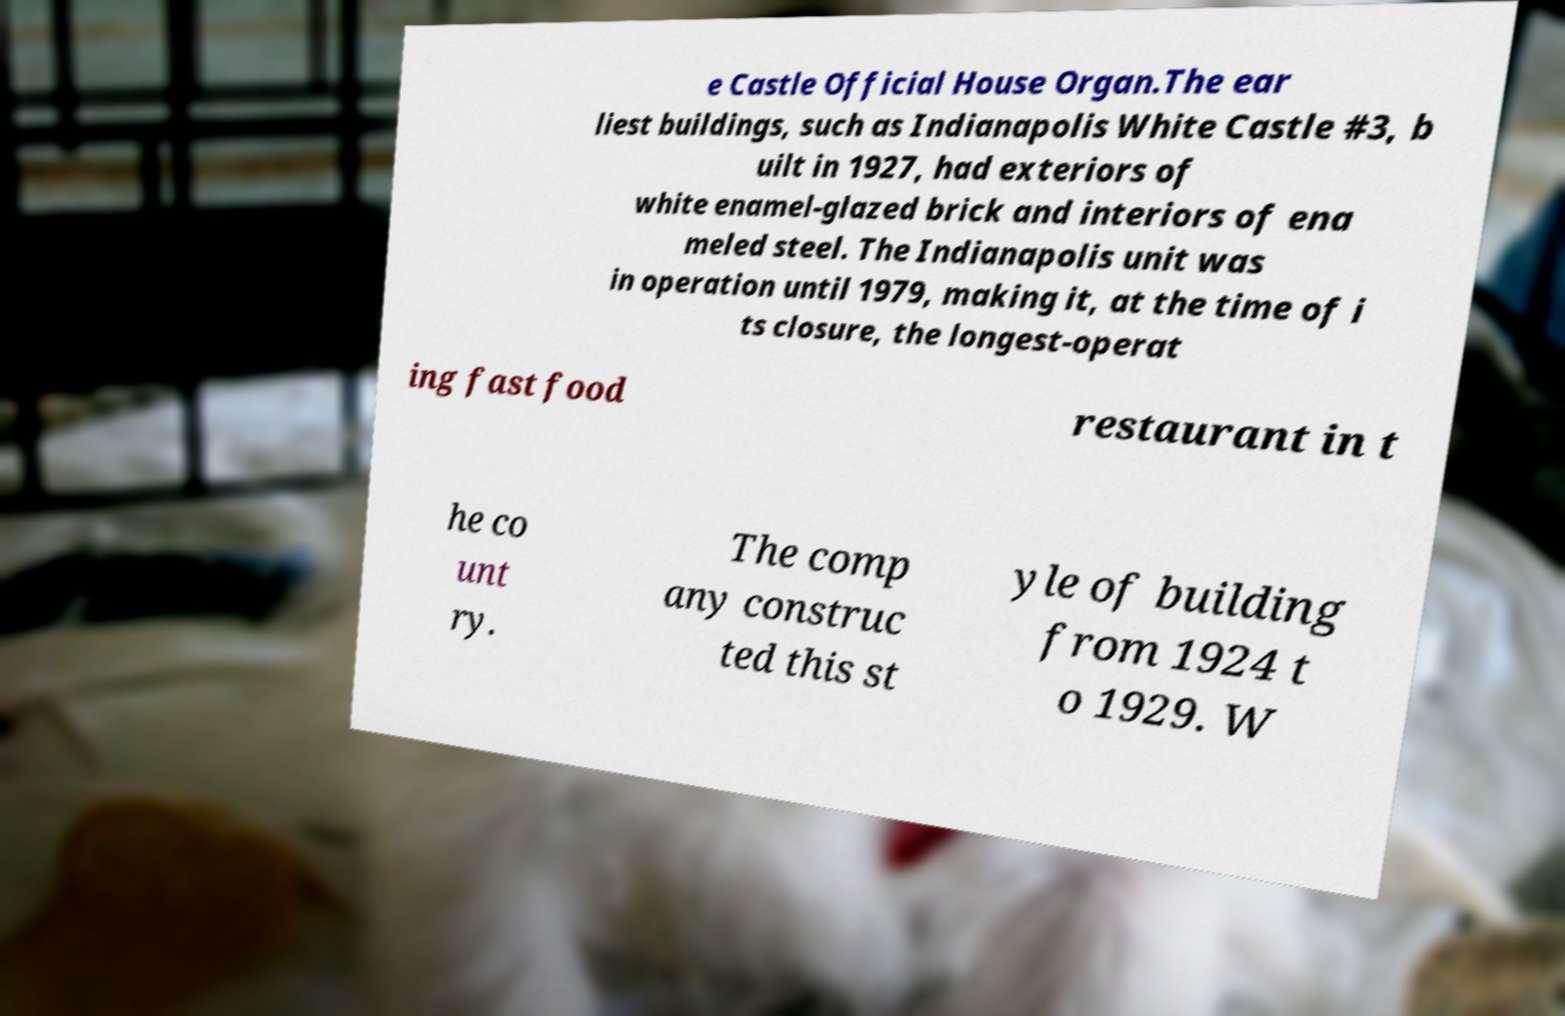Could you extract and type out the text from this image? e Castle Official House Organ.The ear liest buildings, such as Indianapolis White Castle #3, b uilt in 1927, had exteriors of white enamel-glazed brick and interiors of ena meled steel. The Indianapolis unit was in operation until 1979, making it, at the time of i ts closure, the longest-operat ing fast food restaurant in t he co unt ry. The comp any construc ted this st yle of building from 1924 t o 1929. W 